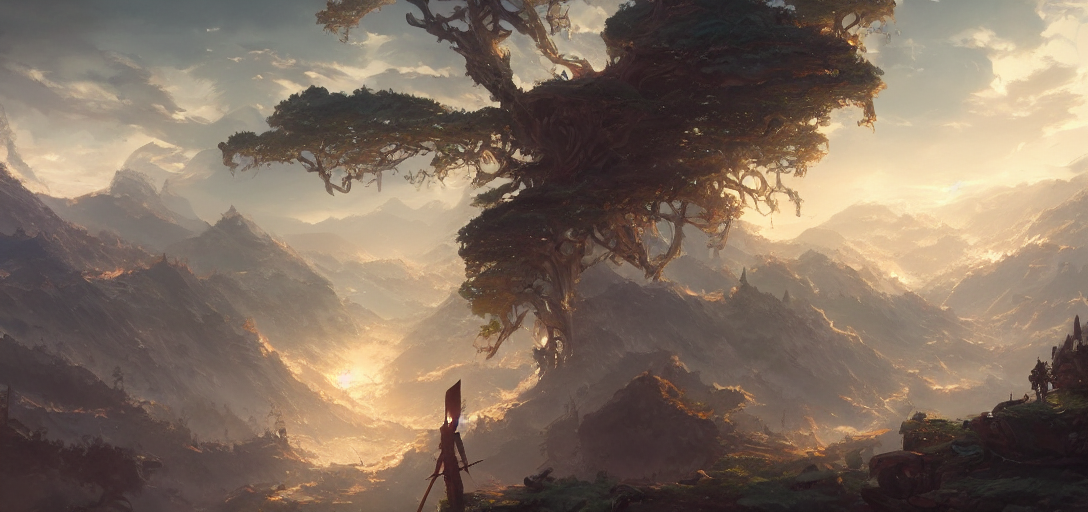What might be the significance of the lone figure standing near the tree? The solitary figure beside the majestic tree could symbolize a seeker or a guardian of the land. Their presence adds a narrative quality, suggesting a story about exploration, guardianship, or communion with nature. 